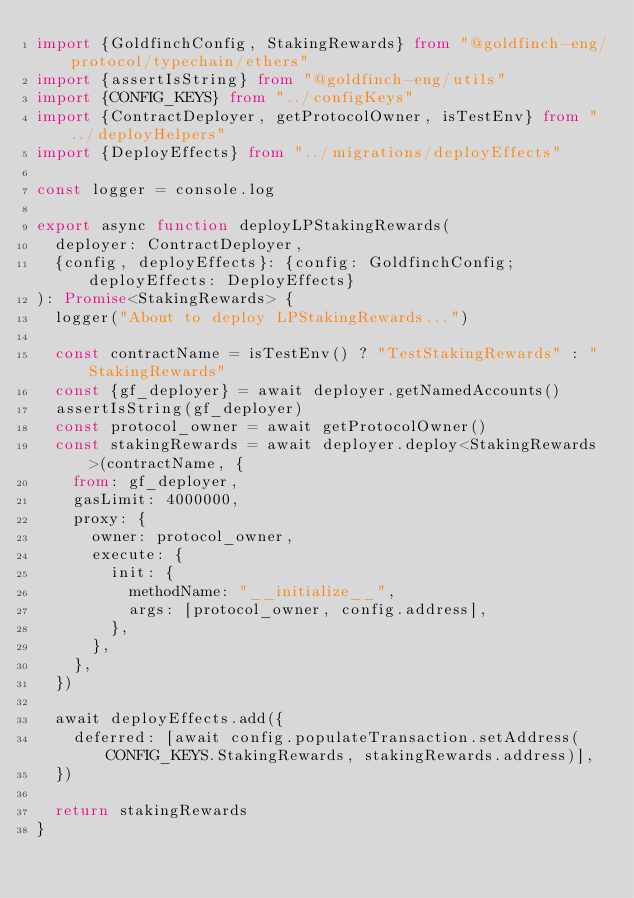Convert code to text. <code><loc_0><loc_0><loc_500><loc_500><_TypeScript_>import {GoldfinchConfig, StakingRewards} from "@goldfinch-eng/protocol/typechain/ethers"
import {assertIsString} from "@goldfinch-eng/utils"
import {CONFIG_KEYS} from "../configKeys"
import {ContractDeployer, getProtocolOwner, isTestEnv} from "../deployHelpers"
import {DeployEffects} from "../migrations/deployEffects"

const logger = console.log

export async function deployLPStakingRewards(
  deployer: ContractDeployer,
  {config, deployEffects}: {config: GoldfinchConfig; deployEffects: DeployEffects}
): Promise<StakingRewards> {
  logger("About to deploy LPStakingRewards...")

  const contractName = isTestEnv() ? "TestStakingRewards" : "StakingRewards"
  const {gf_deployer} = await deployer.getNamedAccounts()
  assertIsString(gf_deployer)
  const protocol_owner = await getProtocolOwner()
  const stakingRewards = await deployer.deploy<StakingRewards>(contractName, {
    from: gf_deployer,
    gasLimit: 4000000,
    proxy: {
      owner: protocol_owner,
      execute: {
        init: {
          methodName: "__initialize__",
          args: [protocol_owner, config.address],
        },
      },
    },
  })

  await deployEffects.add({
    deferred: [await config.populateTransaction.setAddress(CONFIG_KEYS.StakingRewards, stakingRewards.address)],
  })

  return stakingRewards
}
</code> 